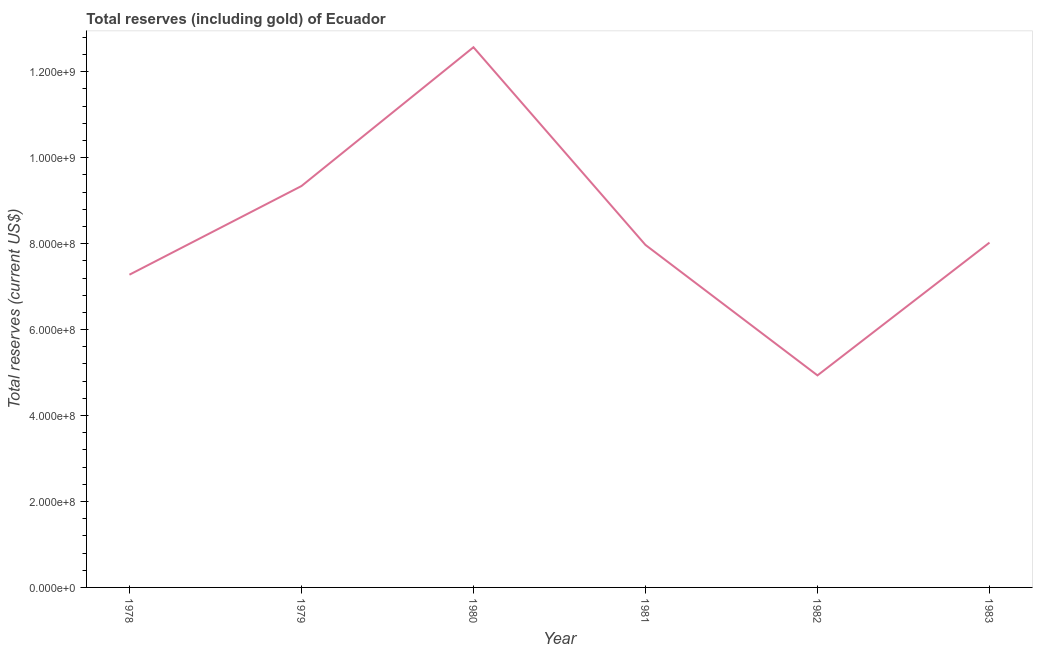What is the total reserves (including gold) in 1980?
Provide a short and direct response. 1.26e+09. Across all years, what is the maximum total reserves (including gold)?
Ensure brevity in your answer.  1.26e+09. Across all years, what is the minimum total reserves (including gold)?
Ensure brevity in your answer.  4.93e+08. In which year was the total reserves (including gold) maximum?
Your answer should be very brief. 1980. What is the sum of the total reserves (including gold)?
Offer a terse response. 5.01e+09. What is the difference between the total reserves (including gold) in 1980 and 1983?
Offer a terse response. 4.55e+08. What is the average total reserves (including gold) per year?
Provide a short and direct response. 8.35e+08. What is the median total reserves (including gold)?
Offer a terse response. 8.00e+08. In how many years, is the total reserves (including gold) greater than 1160000000 US$?
Offer a very short reply. 1. Do a majority of the years between 1979 and 1981 (inclusive) have total reserves (including gold) greater than 120000000 US$?
Offer a very short reply. Yes. What is the ratio of the total reserves (including gold) in 1978 to that in 1981?
Keep it short and to the point. 0.91. Is the total reserves (including gold) in 1979 less than that in 1982?
Keep it short and to the point. No. Is the difference between the total reserves (including gold) in 1980 and 1983 greater than the difference between any two years?
Offer a very short reply. No. What is the difference between the highest and the second highest total reserves (including gold)?
Give a very brief answer. 3.23e+08. What is the difference between the highest and the lowest total reserves (including gold)?
Provide a succinct answer. 7.64e+08. In how many years, is the total reserves (including gold) greater than the average total reserves (including gold) taken over all years?
Offer a very short reply. 2. Does the total reserves (including gold) monotonically increase over the years?
Your response must be concise. No. How many years are there in the graph?
Offer a very short reply. 6. What is the difference between two consecutive major ticks on the Y-axis?
Your response must be concise. 2.00e+08. What is the title of the graph?
Offer a terse response. Total reserves (including gold) of Ecuador. What is the label or title of the X-axis?
Ensure brevity in your answer.  Year. What is the label or title of the Y-axis?
Keep it short and to the point. Total reserves (current US$). What is the Total reserves (current US$) of 1978?
Offer a very short reply. 7.28e+08. What is the Total reserves (current US$) of 1979?
Your answer should be very brief. 9.34e+08. What is the Total reserves (current US$) in 1980?
Provide a succinct answer. 1.26e+09. What is the Total reserves (current US$) in 1981?
Offer a terse response. 7.97e+08. What is the Total reserves (current US$) of 1982?
Keep it short and to the point. 4.93e+08. What is the Total reserves (current US$) in 1983?
Make the answer very short. 8.03e+08. What is the difference between the Total reserves (current US$) in 1978 and 1979?
Offer a terse response. -2.06e+08. What is the difference between the Total reserves (current US$) in 1978 and 1980?
Offer a very short reply. -5.29e+08. What is the difference between the Total reserves (current US$) in 1978 and 1981?
Your answer should be compact. -6.93e+07. What is the difference between the Total reserves (current US$) in 1978 and 1982?
Keep it short and to the point. 2.34e+08. What is the difference between the Total reserves (current US$) in 1978 and 1983?
Your answer should be compact. -7.47e+07. What is the difference between the Total reserves (current US$) in 1979 and 1980?
Provide a succinct answer. -3.23e+08. What is the difference between the Total reserves (current US$) in 1979 and 1981?
Your answer should be very brief. 1.37e+08. What is the difference between the Total reserves (current US$) in 1979 and 1982?
Provide a short and direct response. 4.41e+08. What is the difference between the Total reserves (current US$) in 1979 and 1983?
Offer a terse response. 1.32e+08. What is the difference between the Total reserves (current US$) in 1980 and 1981?
Your response must be concise. 4.60e+08. What is the difference between the Total reserves (current US$) in 1980 and 1982?
Your response must be concise. 7.64e+08. What is the difference between the Total reserves (current US$) in 1980 and 1983?
Make the answer very short. 4.55e+08. What is the difference between the Total reserves (current US$) in 1981 and 1982?
Provide a short and direct response. 3.04e+08. What is the difference between the Total reserves (current US$) in 1981 and 1983?
Your response must be concise. -5.44e+06. What is the difference between the Total reserves (current US$) in 1982 and 1983?
Make the answer very short. -3.09e+08. What is the ratio of the Total reserves (current US$) in 1978 to that in 1979?
Your response must be concise. 0.78. What is the ratio of the Total reserves (current US$) in 1978 to that in 1980?
Provide a short and direct response. 0.58. What is the ratio of the Total reserves (current US$) in 1978 to that in 1981?
Offer a terse response. 0.91. What is the ratio of the Total reserves (current US$) in 1978 to that in 1982?
Ensure brevity in your answer.  1.48. What is the ratio of the Total reserves (current US$) in 1978 to that in 1983?
Keep it short and to the point. 0.91. What is the ratio of the Total reserves (current US$) in 1979 to that in 1980?
Your answer should be compact. 0.74. What is the ratio of the Total reserves (current US$) in 1979 to that in 1981?
Keep it short and to the point. 1.17. What is the ratio of the Total reserves (current US$) in 1979 to that in 1982?
Your answer should be compact. 1.89. What is the ratio of the Total reserves (current US$) in 1979 to that in 1983?
Offer a very short reply. 1.16. What is the ratio of the Total reserves (current US$) in 1980 to that in 1981?
Your answer should be compact. 1.58. What is the ratio of the Total reserves (current US$) in 1980 to that in 1982?
Your answer should be very brief. 2.55. What is the ratio of the Total reserves (current US$) in 1980 to that in 1983?
Give a very brief answer. 1.57. What is the ratio of the Total reserves (current US$) in 1981 to that in 1982?
Offer a very short reply. 1.61. What is the ratio of the Total reserves (current US$) in 1981 to that in 1983?
Provide a succinct answer. 0.99. What is the ratio of the Total reserves (current US$) in 1982 to that in 1983?
Make the answer very short. 0.61. 